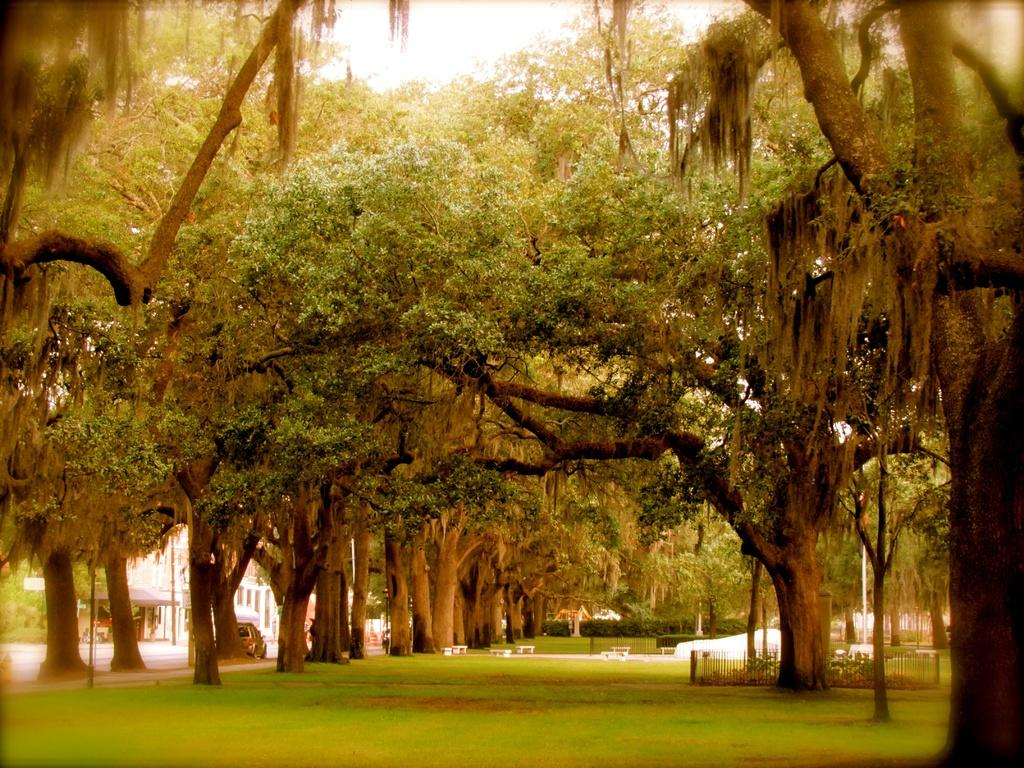What type of vegetation can be seen in the image? There are trees and grass in the image. What type of barrier is present in the image? There is a fence in the image. What can be seen in the background of the image? In the background, there are poles, plants, a building, a vehicle, a board, and benches. What type of loss is being experienced by the brick in the image? There is no brick present in the image, so it is not possible to determine if any loss is being experienced. 